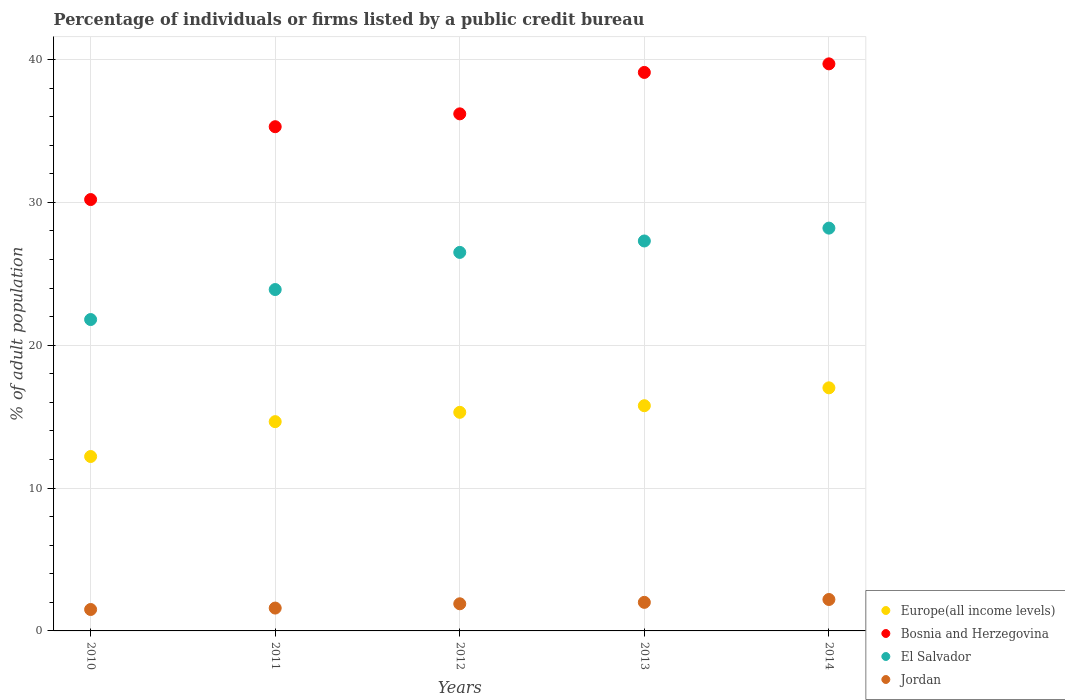How many different coloured dotlines are there?
Provide a succinct answer. 4. Is the number of dotlines equal to the number of legend labels?
Give a very brief answer. Yes. What is the percentage of population listed by a public credit bureau in Jordan in 2011?
Your answer should be very brief. 1.6. Across all years, what is the maximum percentage of population listed by a public credit bureau in Europe(all income levels)?
Your response must be concise. 17.02. Across all years, what is the minimum percentage of population listed by a public credit bureau in Europe(all income levels)?
Make the answer very short. 12.21. In which year was the percentage of population listed by a public credit bureau in Jordan maximum?
Offer a very short reply. 2014. In which year was the percentage of population listed by a public credit bureau in El Salvador minimum?
Your answer should be compact. 2010. What is the difference between the percentage of population listed by a public credit bureau in Jordan in 2010 and that in 2011?
Ensure brevity in your answer.  -0.1. What is the difference between the percentage of population listed by a public credit bureau in Europe(all income levels) in 2013 and the percentage of population listed by a public credit bureau in Jordan in 2012?
Give a very brief answer. 13.87. What is the average percentage of population listed by a public credit bureau in Jordan per year?
Offer a very short reply. 1.84. In the year 2013, what is the difference between the percentage of population listed by a public credit bureau in Bosnia and Herzegovina and percentage of population listed by a public credit bureau in Europe(all income levels)?
Ensure brevity in your answer.  23.33. In how many years, is the percentage of population listed by a public credit bureau in Bosnia and Herzegovina greater than 20 %?
Your answer should be compact. 5. What is the ratio of the percentage of population listed by a public credit bureau in Bosnia and Herzegovina in 2012 to that in 2013?
Provide a succinct answer. 0.93. What is the difference between the highest and the second highest percentage of population listed by a public credit bureau in El Salvador?
Ensure brevity in your answer.  0.9. What is the difference between the highest and the lowest percentage of population listed by a public credit bureau in Jordan?
Offer a terse response. 0.7. In how many years, is the percentage of population listed by a public credit bureau in Europe(all income levels) greater than the average percentage of population listed by a public credit bureau in Europe(all income levels) taken over all years?
Make the answer very short. 3. Is the percentage of population listed by a public credit bureau in Jordan strictly less than the percentage of population listed by a public credit bureau in Bosnia and Herzegovina over the years?
Make the answer very short. Yes. How many dotlines are there?
Your answer should be very brief. 4. What is the difference between two consecutive major ticks on the Y-axis?
Provide a succinct answer. 10. Are the values on the major ticks of Y-axis written in scientific E-notation?
Your answer should be very brief. No. Does the graph contain grids?
Make the answer very short. Yes. What is the title of the graph?
Your answer should be compact. Percentage of individuals or firms listed by a public credit bureau. Does "Monaco" appear as one of the legend labels in the graph?
Keep it short and to the point. No. What is the label or title of the X-axis?
Your response must be concise. Years. What is the label or title of the Y-axis?
Ensure brevity in your answer.  % of adult population. What is the % of adult population of Europe(all income levels) in 2010?
Your response must be concise. 12.21. What is the % of adult population in Bosnia and Herzegovina in 2010?
Ensure brevity in your answer.  30.2. What is the % of adult population of El Salvador in 2010?
Provide a short and direct response. 21.8. What is the % of adult population in Europe(all income levels) in 2011?
Give a very brief answer. 14.65. What is the % of adult population in Bosnia and Herzegovina in 2011?
Your response must be concise. 35.3. What is the % of adult population of El Salvador in 2011?
Provide a short and direct response. 23.9. What is the % of adult population of Europe(all income levels) in 2012?
Give a very brief answer. 15.3. What is the % of adult population of Bosnia and Herzegovina in 2012?
Ensure brevity in your answer.  36.2. What is the % of adult population in El Salvador in 2012?
Your answer should be very brief. 26.5. What is the % of adult population in Jordan in 2012?
Offer a terse response. 1.9. What is the % of adult population in Europe(all income levels) in 2013?
Give a very brief answer. 15.77. What is the % of adult population in Bosnia and Herzegovina in 2013?
Give a very brief answer. 39.1. What is the % of adult population of El Salvador in 2013?
Provide a succinct answer. 27.3. What is the % of adult population in Europe(all income levels) in 2014?
Offer a very short reply. 17.02. What is the % of adult population of Bosnia and Herzegovina in 2014?
Your answer should be very brief. 39.7. What is the % of adult population of El Salvador in 2014?
Keep it short and to the point. 28.2. Across all years, what is the maximum % of adult population in Europe(all income levels)?
Ensure brevity in your answer.  17.02. Across all years, what is the maximum % of adult population in Bosnia and Herzegovina?
Make the answer very short. 39.7. Across all years, what is the maximum % of adult population in El Salvador?
Your answer should be very brief. 28.2. Across all years, what is the maximum % of adult population in Jordan?
Offer a terse response. 2.2. Across all years, what is the minimum % of adult population in Europe(all income levels)?
Make the answer very short. 12.21. Across all years, what is the minimum % of adult population in Bosnia and Herzegovina?
Offer a terse response. 30.2. Across all years, what is the minimum % of adult population of El Salvador?
Ensure brevity in your answer.  21.8. What is the total % of adult population of Europe(all income levels) in the graph?
Your answer should be very brief. 74.95. What is the total % of adult population in Bosnia and Herzegovina in the graph?
Make the answer very short. 180.5. What is the total % of adult population in El Salvador in the graph?
Your answer should be compact. 127.7. What is the total % of adult population of Jordan in the graph?
Your answer should be very brief. 9.2. What is the difference between the % of adult population in Europe(all income levels) in 2010 and that in 2011?
Your answer should be compact. -2.44. What is the difference between the % of adult population of Bosnia and Herzegovina in 2010 and that in 2011?
Offer a terse response. -5.1. What is the difference between the % of adult population in Europe(all income levels) in 2010 and that in 2012?
Make the answer very short. -3.09. What is the difference between the % of adult population in El Salvador in 2010 and that in 2012?
Offer a terse response. -4.7. What is the difference between the % of adult population of Europe(all income levels) in 2010 and that in 2013?
Make the answer very short. -3.56. What is the difference between the % of adult population of Europe(all income levels) in 2010 and that in 2014?
Your answer should be very brief. -4.81. What is the difference between the % of adult population of Jordan in 2010 and that in 2014?
Offer a terse response. -0.7. What is the difference between the % of adult population in Europe(all income levels) in 2011 and that in 2012?
Provide a short and direct response. -0.65. What is the difference between the % of adult population in Bosnia and Herzegovina in 2011 and that in 2012?
Your response must be concise. -0.9. What is the difference between the % of adult population of Europe(all income levels) in 2011 and that in 2013?
Give a very brief answer. -1.12. What is the difference between the % of adult population of Jordan in 2011 and that in 2013?
Your answer should be compact. -0.4. What is the difference between the % of adult population of Europe(all income levels) in 2011 and that in 2014?
Offer a terse response. -2.37. What is the difference between the % of adult population in Bosnia and Herzegovina in 2011 and that in 2014?
Your response must be concise. -4.4. What is the difference between the % of adult population in El Salvador in 2011 and that in 2014?
Provide a succinct answer. -4.3. What is the difference between the % of adult population of Europe(all income levels) in 2012 and that in 2013?
Your answer should be very brief. -0.46. What is the difference between the % of adult population in Bosnia and Herzegovina in 2012 and that in 2013?
Offer a very short reply. -2.9. What is the difference between the % of adult population in El Salvador in 2012 and that in 2013?
Offer a very short reply. -0.8. What is the difference between the % of adult population of Jordan in 2012 and that in 2013?
Your response must be concise. -0.1. What is the difference between the % of adult population in Europe(all income levels) in 2012 and that in 2014?
Offer a very short reply. -1.71. What is the difference between the % of adult population in Europe(all income levels) in 2013 and that in 2014?
Make the answer very short. -1.25. What is the difference between the % of adult population in El Salvador in 2013 and that in 2014?
Your answer should be very brief. -0.9. What is the difference between the % of adult population of Jordan in 2013 and that in 2014?
Offer a terse response. -0.2. What is the difference between the % of adult population in Europe(all income levels) in 2010 and the % of adult population in Bosnia and Herzegovina in 2011?
Keep it short and to the point. -23.09. What is the difference between the % of adult population of Europe(all income levels) in 2010 and the % of adult population of El Salvador in 2011?
Offer a very short reply. -11.69. What is the difference between the % of adult population in Europe(all income levels) in 2010 and the % of adult population in Jordan in 2011?
Your answer should be compact. 10.61. What is the difference between the % of adult population of Bosnia and Herzegovina in 2010 and the % of adult population of Jordan in 2011?
Your answer should be very brief. 28.6. What is the difference between the % of adult population in El Salvador in 2010 and the % of adult population in Jordan in 2011?
Keep it short and to the point. 20.2. What is the difference between the % of adult population of Europe(all income levels) in 2010 and the % of adult population of Bosnia and Herzegovina in 2012?
Offer a very short reply. -23.99. What is the difference between the % of adult population in Europe(all income levels) in 2010 and the % of adult population in El Salvador in 2012?
Give a very brief answer. -14.29. What is the difference between the % of adult population of Europe(all income levels) in 2010 and the % of adult population of Jordan in 2012?
Make the answer very short. 10.31. What is the difference between the % of adult population of Bosnia and Herzegovina in 2010 and the % of adult population of Jordan in 2012?
Make the answer very short. 28.3. What is the difference between the % of adult population of El Salvador in 2010 and the % of adult population of Jordan in 2012?
Give a very brief answer. 19.9. What is the difference between the % of adult population in Europe(all income levels) in 2010 and the % of adult population in Bosnia and Herzegovina in 2013?
Offer a very short reply. -26.89. What is the difference between the % of adult population in Europe(all income levels) in 2010 and the % of adult population in El Salvador in 2013?
Your answer should be very brief. -15.09. What is the difference between the % of adult population in Europe(all income levels) in 2010 and the % of adult population in Jordan in 2013?
Make the answer very short. 10.21. What is the difference between the % of adult population of Bosnia and Herzegovina in 2010 and the % of adult population of El Salvador in 2013?
Ensure brevity in your answer.  2.9. What is the difference between the % of adult population of Bosnia and Herzegovina in 2010 and the % of adult population of Jordan in 2013?
Provide a short and direct response. 28.2. What is the difference between the % of adult population of El Salvador in 2010 and the % of adult population of Jordan in 2013?
Your response must be concise. 19.8. What is the difference between the % of adult population of Europe(all income levels) in 2010 and the % of adult population of Bosnia and Herzegovina in 2014?
Provide a short and direct response. -27.49. What is the difference between the % of adult population of Europe(all income levels) in 2010 and the % of adult population of El Salvador in 2014?
Offer a terse response. -15.99. What is the difference between the % of adult population in Europe(all income levels) in 2010 and the % of adult population in Jordan in 2014?
Make the answer very short. 10.01. What is the difference between the % of adult population in Bosnia and Herzegovina in 2010 and the % of adult population in El Salvador in 2014?
Provide a succinct answer. 2. What is the difference between the % of adult population of Bosnia and Herzegovina in 2010 and the % of adult population of Jordan in 2014?
Your response must be concise. 28. What is the difference between the % of adult population in El Salvador in 2010 and the % of adult population in Jordan in 2014?
Provide a succinct answer. 19.6. What is the difference between the % of adult population in Europe(all income levels) in 2011 and the % of adult population in Bosnia and Herzegovina in 2012?
Provide a succinct answer. -21.55. What is the difference between the % of adult population in Europe(all income levels) in 2011 and the % of adult population in El Salvador in 2012?
Your answer should be compact. -11.85. What is the difference between the % of adult population of Europe(all income levels) in 2011 and the % of adult population of Jordan in 2012?
Provide a succinct answer. 12.75. What is the difference between the % of adult population of Bosnia and Herzegovina in 2011 and the % of adult population of El Salvador in 2012?
Offer a very short reply. 8.8. What is the difference between the % of adult population of Bosnia and Herzegovina in 2011 and the % of adult population of Jordan in 2012?
Ensure brevity in your answer.  33.4. What is the difference between the % of adult population in El Salvador in 2011 and the % of adult population in Jordan in 2012?
Your response must be concise. 22. What is the difference between the % of adult population of Europe(all income levels) in 2011 and the % of adult population of Bosnia and Herzegovina in 2013?
Your response must be concise. -24.45. What is the difference between the % of adult population of Europe(all income levels) in 2011 and the % of adult population of El Salvador in 2013?
Offer a terse response. -12.65. What is the difference between the % of adult population in Europe(all income levels) in 2011 and the % of adult population in Jordan in 2013?
Offer a very short reply. 12.65. What is the difference between the % of adult population of Bosnia and Herzegovina in 2011 and the % of adult population of Jordan in 2013?
Your answer should be compact. 33.3. What is the difference between the % of adult population of El Salvador in 2011 and the % of adult population of Jordan in 2013?
Provide a succinct answer. 21.9. What is the difference between the % of adult population of Europe(all income levels) in 2011 and the % of adult population of Bosnia and Herzegovina in 2014?
Make the answer very short. -25.05. What is the difference between the % of adult population of Europe(all income levels) in 2011 and the % of adult population of El Salvador in 2014?
Give a very brief answer. -13.55. What is the difference between the % of adult population of Europe(all income levels) in 2011 and the % of adult population of Jordan in 2014?
Keep it short and to the point. 12.45. What is the difference between the % of adult population of Bosnia and Herzegovina in 2011 and the % of adult population of El Salvador in 2014?
Your answer should be compact. 7.1. What is the difference between the % of adult population of Bosnia and Herzegovina in 2011 and the % of adult population of Jordan in 2014?
Provide a succinct answer. 33.1. What is the difference between the % of adult population in El Salvador in 2011 and the % of adult population in Jordan in 2014?
Your answer should be very brief. 21.7. What is the difference between the % of adult population of Europe(all income levels) in 2012 and the % of adult population of Bosnia and Herzegovina in 2013?
Give a very brief answer. -23.8. What is the difference between the % of adult population in Europe(all income levels) in 2012 and the % of adult population in El Salvador in 2013?
Offer a very short reply. -12. What is the difference between the % of adult population of Europe(all income levels) in 2012 and the % of adult population of Jordan in 2013?
Keep it short and to the point. 13.3. What is the difference between the % of adult population of Bosnia and Herzegovina in 2012 and the % of adult population of El Salvador in 2013?
Offer a terse response. 8.9. What is the difference between the % of adult population in Bosnia and Herzegovina in 2012 and the % of adult population in Jordan in 2013?
Keep it short and to the point. 34.2. What is the difference between the % of adult population of Europe(all income levels) in 2012 and the % of adult population of Bosnia and Herzegovina in 2014?
Ensure brevity in your answer.  -24.4. What is the difference between the % of adult population of Europe(all income levels) in 2012 and the % of adult population of El Salvador in 2014?
Your answer should be very brief. -12.9. What is the difference between the % of adult population of Europe(all income levels) in 2012 and the % of adult population of Jordan in 2014?
Offer a terse response. 13.1. What is the difference between the % of adult population of Bosnia and Herzegovina in 2012 and the % of adult population of Jordan in 2014?
Offer a terse response. 34. What is the difference between the % of adult population of El Salvador in 2012 and the % of adult population of Jordan in 2014?
Your answer should be compact. 24.3. What is the difference between the % of adult population of Europe(all income levels) in 2013 and the % of adult population of Bosnia and Herzegovina in 2014?
Keep it short and to the point. -23.93. What is the difference between the % of adult population in Europe(all income levels) in 2013 and the % of adult population in El Salvador in 2014?
Make the answer very short. -12.43. What is the difference between the % of adult population in Europe(all income levels) in 2013 and the % of adult population in Jordan in 2014?
Your answer should be very brief. 13.57. What is the difference between the % of adult population of Bosnia and Herzegovina in 2013 and the % of adult population of El Salvador in 2014?
Keep it short and to the point. 10.9. What is the difference between the % of adult population of Bosnia and Herzegovina in 2013 and the % of adult population of Jordan in 2014?
Give a very brief answer. 36.9. What is the difference between the % of adult population in El Salvador in 2013 and the % of adult population in Jordan in 2014?
Offer a very short reply. 25.1. What is the average % of adult population of Europe(all income levels) per year?
Offer a terse response. 14.99. What is the average % of adult population of Bosnia and Herzegovina per year?
Offer a very short reply. 36.1. What is the average % of adult population of El Salvador per year?
Your answer should be very brief. 25.54. What is the average % of adult population in Jordan per year?
Keep it short and to the point. 1.84. In the year 2010, what is the difference between the % of adult population in Europe(all income levels) and % of adult population in Bosnia and Herzegovina?
Give a very brief answer. -17.99. In the year 2010, what is the difference between the % of adult population of Europe(all income levels) and % of adult population of El Salvador?
Offer a very short reply. -9.59. In the year 2010, what is the difference between the % of adult population of Europe(all income levels) and % of adult population of Jordan?
Provide a succinct answer. 10.71. In the year 2010, what is the difference between the % of adult population in Bosnia and Herzegovina and % of adult population in Jordan?
Give a very brief answer. 28.7. In the year 2010, what is the difference between the % of adult population in El Salvador and % of adult population in Jordan?
Make the answer very short. 20.3. In the year 2011, what is the difference between the % of adult population of Europe(all income levels) and % of adult population of Bosnia and Herzegovina?
Offer a terse response. -20.65. In the year 2011, what is the difference between the % of adult population in Europe(all income levels) and % of adult population in El Salvador?
Provide a short and direct response. -9.25. In the year 2011, what is the difference between the % of adult population of Europe(all income levels) and % of adult population of Jordan?
Your answer should be compact. 13.05. In the year 2011, what is the difference between the % of adult population of Bosnia and Herzegovina and % of adult population of Jordan?
Make the answer very short. 33.7. In the year 2011, what is the difference between the % of adult population of El Salvador and % of adult population of Jordan?
Offer a very short reply. 22.3. In the year 2012, what is the difference between the % of adult population of Europe(all income levels) and % of adult population of Bosnia and Herzegovina?
Offer a very short reply. -20.9. In the year 2012, what is the difference between the % of adult population of Europe(all income levels) and % of adult population of El Salvador?
Your answer should be very brief. -11.2. In the year 2012, what is the difference between the % of adult population in Europe(all income levels) and % of adult population in Jordan?
Your answer should be very brief. 13.4. In the year 2012, what is the difference between the % of adult population of Bosnia and Herzegovina and % of adult population of Jordan?
Make the answer very short. 34.3. In the year 2012, what is the difference between the % of adult population in El Salvador and % of adult population in Jordan?
Your response must be concise. 24.6. In the year 2013, what is the difference between the % of adult population of Europe(all income levels) and % of adult population of Bosnia and Herzegovina?
Your answer should be very brief. -23.33. In the year 2013, what is the difference between the % of adult population in Europe(all income levels) and % of adult population in El Salvador?
Your response must be concise. -11.53. In the year 2013, what is the difference between the % of adult population of Europe(all income levels) and % of adult population of Jordan?
Keep it short and to the point. 13.77. In the year 2013, what is the difference between the % of adult population of Bosnia and Herzegovina and % of adult population of Jordan?
Your answer should be very brief. 37.1. In the year 2013, what is the difference between the % of adult population in El Salvador and % of adult population in Jordan?
Provide a short and direct response. 25.3. In the year 2014, what is the difference between the % of adult population in Europe(all income levels) and % of adult population in Bosnia and Herzegovina?
Your answer should be very brief. -22.68. In the year 2014, what is the difference between the % of adult population of Europe(all income levels) and % of adult population of El Salvador?
Keep it short and to the point. -11.18. In the year 2014, what is the difference between the % of adult population of Europe(all income levels) and % of adult population of Jordan?
Offer a terse response. 14.82. In the year 2014, what is the difference between the % of adult population of Bosnia and Herzegovina and % of adult population of El Salvador?
Your response must be concise. 11.5. In the year 2014, what is the difference between the % of adult population of Bosnia and Herzegovina and % of adult population of Jordan?
Your answer should be very brief. 37.5. What is the ratio of the % of adult population of Europe(all income levels) in 2010 to that in 2011?
Your response must be concise. 0.83. What is the ratio of the % of adult population in Bosnia and Herzegovina in 2010 to that in 2011?
Make the answer very short. 0.86. What is the ratio of the % of adult population in El Salvador in 2010 to that in 2011?
Your answer should be compact. 0.91. What is the ratio of the % of adult population of Jordan in 2010 to that in 2011?
Your answer should be compact. 0.94. What is the ratio of the % of adult population in Europe(all income levels) in 2010 to that in 2012?
Offer a very short reply. 0.8. What is the ratio of the % of adult population in Bosnia and Herzegovina in 2010 to that in 2012?
Offer a very short reply. 0.83. What is the ratio of the % of adult population of El Salvador in 2010 to that in 2012?
Your response must be concise. 0.82. What is the ratio of the % of adult population of Jordan in 2010 to that in 2012?
Make the answer very short. 0.79. What is the ratio of the % of adult population in Europe(all income levels) in 2010 to that in 2013?
Offer a terse response. 0.77. What is the ratio of the % of adult population in Bosnia and Herzegovina in 2010 to that in 2013?
Ensure brevity in your answer.  0.77. What is the ratio of the % of adult population in El Salvador in 2010 to that in 2013?
Provide a succinct answer. 0.8. What is the ratio of the % of adult population in Jordan in 2010 to that in 2013?
Your answer should be very brief. 0.75. What is the ratio of the % of adult population of Europe(all income levels) in 2010 to that in 2014?
Ensure brevity in your answer.  0.72. What is the ratio of the % of adult population of Bosnia and Herzegovina in 2010 to that in 2014?
Provide a succinct answer. 0.76. What is the ratio of the % of adult population of El Salvador in 2010 to that in 2014?
Offer a terse response. 0.77. What is the ratio of the % of adult population of Jordan in 2010 to that in 2014?
Give a very brief answer. 0.68. What is the ratio of the % of adult population in Europe(all income levels) in 2011 to that in 2012?
Make the answer very short. 0.96. What is the ratio of the % of adult population in Bosnia and Herzegovina in 2011 to that in 2012?
Give a very brief answer. 0.98. What is the ratio of the % of adult population of El Salvador in 2011 to that in 2012?
Give a very brief answer. 0.9. What is the ratio of the % of adult population in Jordan in 2011 to that in 2012?
Offer a very short reply. 0.84. What is the ratio of the % of adult population of Europe(all income levels) in 2011 to that in 2013?
Your answer should be very brief. 0.93. What is the ratio of the % of adult population of Bosnia and Herzegovina in 2011 to that in 2013?
Keep it short and to the point. 0.9. What is the ratio of the % of adult population of El Salvador in 2011 to that in 2013?
Offer a terse response. 0.88. What is the ratio of the % of adult population in Europe(all income levels) in 2011 to that in 2014?
Provide a short and direct response. 0.86. What is the ratio of the % of adult population in Bosnia and Herzegovina in 2011 to that in 2014?
Ensure brevity in your answer.  0.89. What is the ratio of the % of adult population of El Salvador in 2011 to that in 2014?
Offer a terse response. 0.85. What is the ratio of the % of adult population of Jordan in 2011 to that in 2014?
Give a very brief answer. 0.73. What is the ratio of the % of adult population in Europe(all income levels) in 2012 to that in 2013?
Offer a very short reply. 0.97. What is the ratio of the % of adult population in Bosnia and Herzegovina in 2012 to that in 2013?
Keep it short and to the point. 0.93. What is the ratio of the % of adult population in El Salvador in 2012 to that in 2013?
Keep it short and to the point. 0.97. What is the ratio of the % of adult population in Jordan in 2012 to that in 2013?
Offer a very short reply. 0.95. What is the ratio of the % of adult population in Europe(all income levels) in 2012 to that in 2014?
Ensure brevity in your answer.  0.9. What is the ratio of the % of adult population of Bosnia and Herzegovina in 2012 to that in 2014?
Your response must be concise. 0.91. What is the ratio of the % of adult population of El Salvador in 2012 to that in 2014?
Make the answer very short. 0.94. What is the ratio of the % of adult population in Jordan in 2012 to that in 2014?
Provide a short and direct response. 0.86. What is the ratio of the % of adult population in Europe(all income levels) in 2013 to that in 2014?
Provide a short and direct response. 0.93. What is the ratio of the % of adult population in Bosnia and Herzegovina in 2013 to that in 2014?
Provide a succinct answer. 0.98. What is the ratio of the % of adult population of El Salvador in 2013 to that in 2014?
Offer a very short reply. 0.97. What is the ratio of the % of adult population in Jordan in 2013 to that in 2014?
Offer a terse response. 0.91. What is the difference between the highest and the second highest % of adult population in Europe(all income levels)?
Make the answer very short. 1.25. What is the difference between the highest and the second highest % of adult population in El Salvador?
Your answer should be compact. 0.9. What is the difference between the highest and the second highest % of adult population of Jordan?
Your response must be concise. 0.2. What is the difference between the highest and the lowest % of adult population in Europe(all income levels)?
Your answer should be compact. 4.81. What is the difference between the highest and the lowest % of adult population in Jordan?
Offer a terse response. 0.7. 